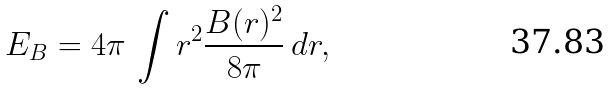Convert formula to latex. <formula><loc_0><loc_0><loc_500><loc_500>E _ { B } = 4 \pi \, \int r ^ { 2 } \frac { B ( r ) ^ { 2 } } { 8 \pi } \, d r ,</formula> 